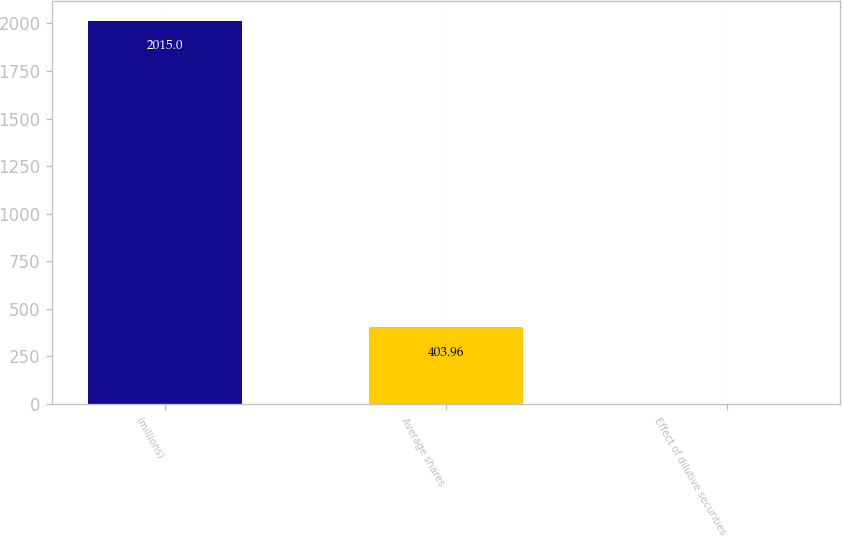Convert chart. <chart><loc_0><loc_0><loc_500><loc_500><bar_chart><fcel>(millions)<fcel>Average shares<fcel>Effect of dilutive securities<nl><fcel>2015<fcel>403.96<fcel>1.2<nl></chart> 